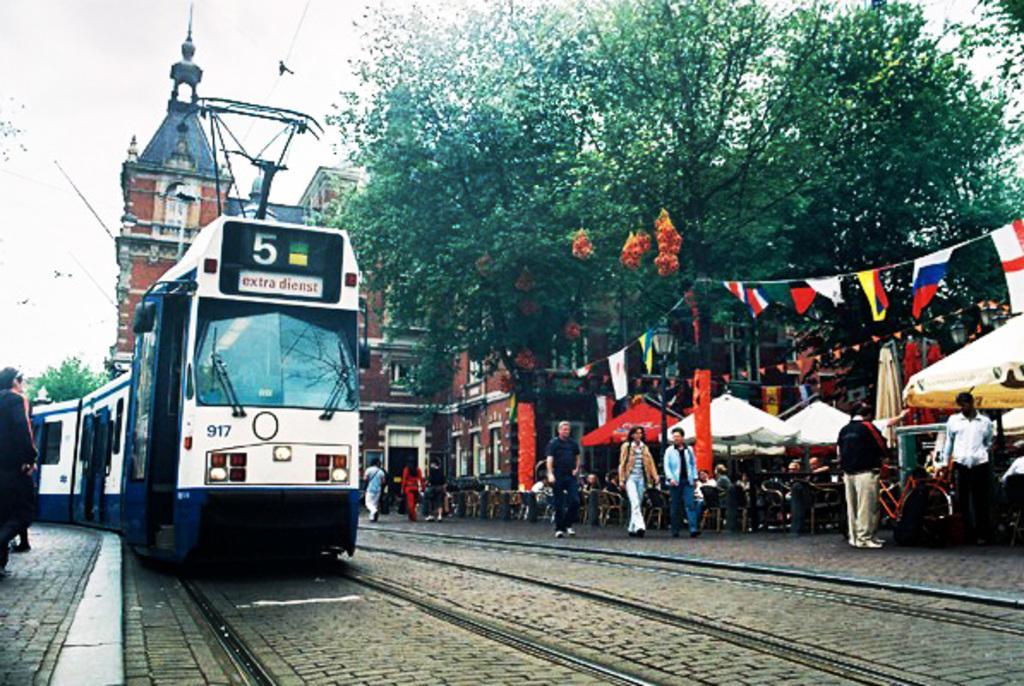In one or two sentences, can you explain what this image depicts? In this image there is a train on the railway track, there are group of people, there are flags, umbrellas, chairs , there is a building, some decorative items, there are trees, and in the background there is sky. 